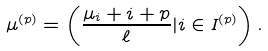<formula> <loc_0><loc_0><loc_500><loc_500>\mu ^ { ( p ) } = \left ( \frac { \mu _ { i } + i + p } { \ell } | i \in I ^ { ( p ) } \right ) .</formula> 